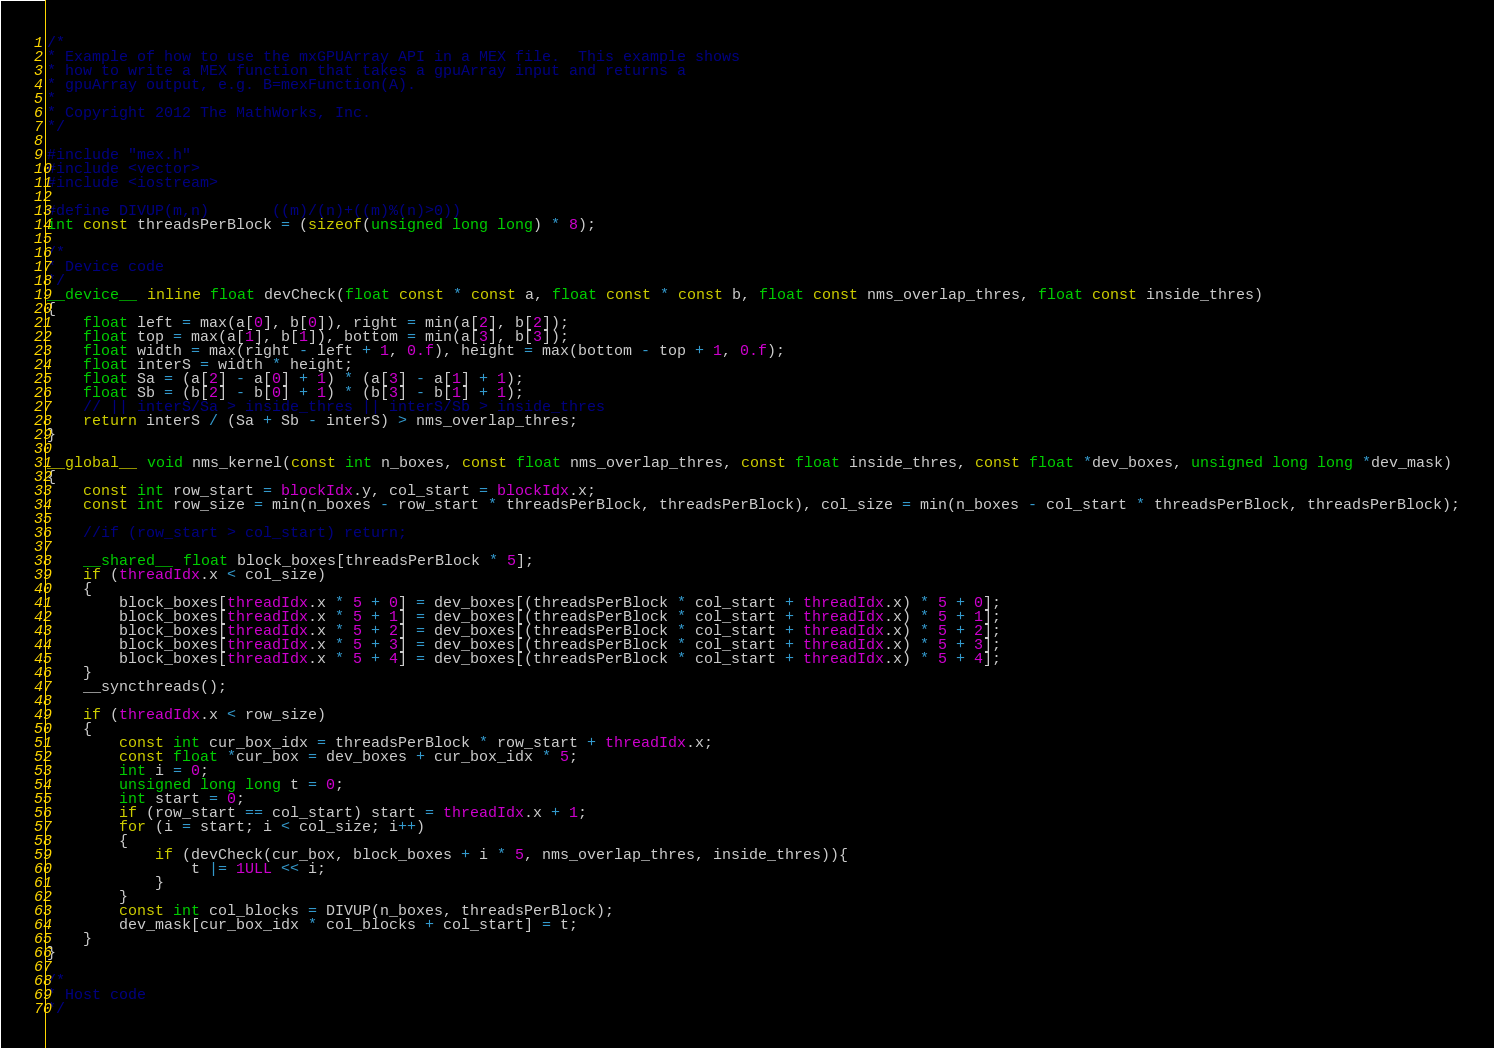Convert code to text. <code><loc_0><loc_0><loc_500><loc_500><_Cuda_>/*
* Example of how to use the mxGPUArray API in a MEX file.  This example shows
* how to write a MEX function that takes a gpuArray input and returns a
* gpuArray output, e.g. B=mexFunction(A).
*
* Copyright 2012 The MathWorks, Inc.
*/

#include "mex.h"
#include <vector>
#include <iostream>

#define DIVUP(m,n)		((m)/(n)+((m)%(n)>0))
int const threadsPerBlock = (sizeof(unsigned long long) * 8);

/*
* Device code
*/
__device__ inline float devCheck(float const * const a, float const * const b, float const nms_overlap_thres, float const inside_thres)
{
	float left = max(a[0], b[0]), right = min(a[2], b[2]);
	float top = max(a[1], b[1]), bottom = min(a[3], b[3]);
	float width = max(right - left + 1, 0.f), height = max(bottom - top + 1, 0.f);
	float interS = width * height;
	float Sa = (a[2] - a[0] + 1) * (a[3] - a[1] + 1);
	float Sb = (b[2] - b[0] + 1) * (b[3] - b[1] + 1);
	// || interS/Sa > inside_thres || interS/Sb > inside_thres
	return interS / (Sa + Sb - interS) > nms_overlap_thres;
}

__global__ void nms_kernel(const int n_boxes, const float nms_overlap_thres, const float inside_thres, const float *dev_boxes, unsigned long long *dev_mask)
{
	const int row_start = blockIdx.y, col_start = blockIdx.x;
	const int row_size = min(n_boxes - row_start * threadsPerBlock, threadsPerBlock), col_size = min(n_boxes - col_start * threadsPerBlock, threadsPerBlock);

	//if (row_start > col_start) return;

	__shared__ float block_boxes[threadsPerBlock * 5];
	if (threadIdx.x < col_size)
	{
		block_boxes[threadIdx.x * 5 + 0] = dev_boxes[(threadsPerBlock * col_start + threadIdx.x) * 5 + 0];
		block_boxes[threadIdx.x * 5 + 1] = dev_boxes[(threadsPerBlock * col_start + threadIdx.x) * 5 + 1];
		block_boxes[threadIdx.x * 5 + 2] = dev_boxes[(threadsPerBlock * col_start + threadIdx.x) * 5 + 2];
		block_boxes[threadIdx.x * 5 + 3] = dev_boxes[(threadsPerBlock * col_start + threadIdx.x) * 5 + 3];
		block_boxes[threadIdx.x * 5 + 4] = dev_boxes[(threadsPerBlock * col_start + threadIdx.x) * 5 + 4];
	}
	__syncthreads();

	if (threadIdx.x < row_size)
	{
		const int cur_box_idx = threadsPerBlock * row_start + threadIdx.x;
		const float *cur_box = dev_boxes + cur_box_idx * 5;
		int i = 0;
		unsigned long long t = 0;
		int start = 0;
		if (row_start == col_start) start = threadIdx.x + 1;
		for (i = start; i < col_size; i++)
		{
			if (devCheck(cur_box, block_boxes + i * 5, nms_overlap_thres, inside_thres)){
				t |= 1ULL << i;
			}
		}
		const int col_blocks = DIVUP(n_boxes, threadsPerBlock);
		dev_mask[cur_box_idx * col_blocks + col_start] = t;
	}
}

/*
* Host code
*/</code> 